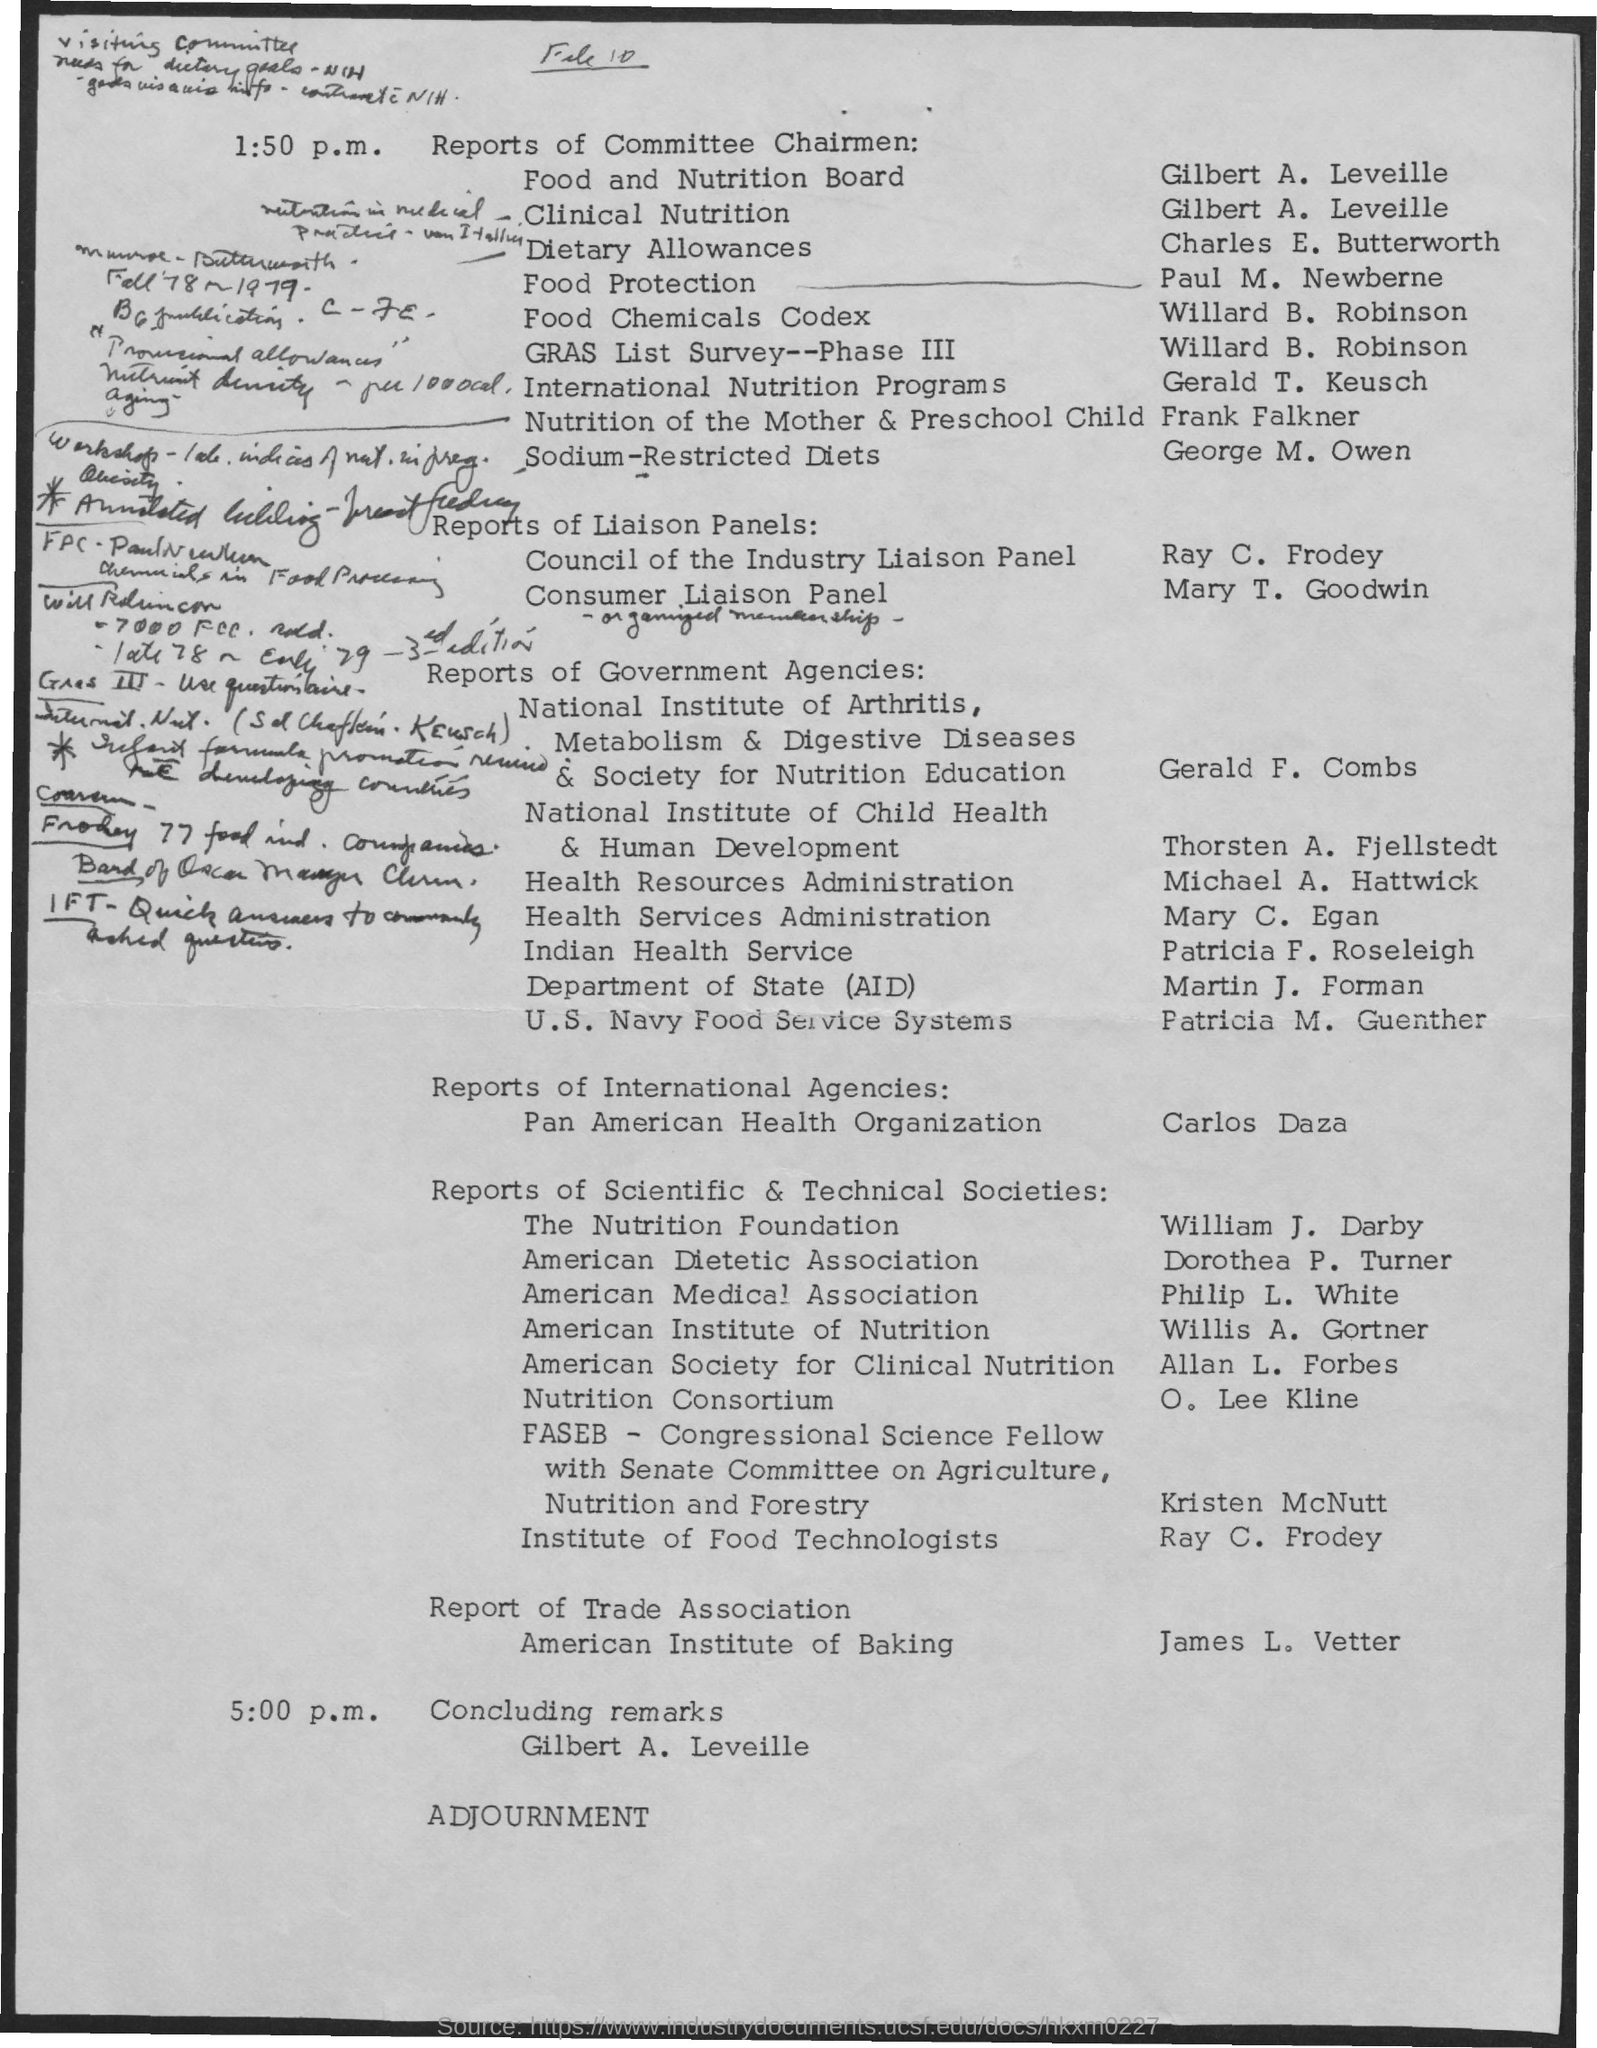Identify some key points in this picture. Gilbert A. Leveille is the chairman of the Food and Nutrition Board. 